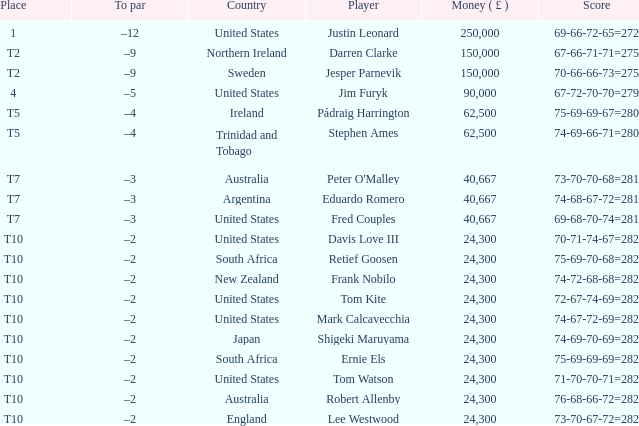What is the sum of winnings for stephen ames? 62500.0. 